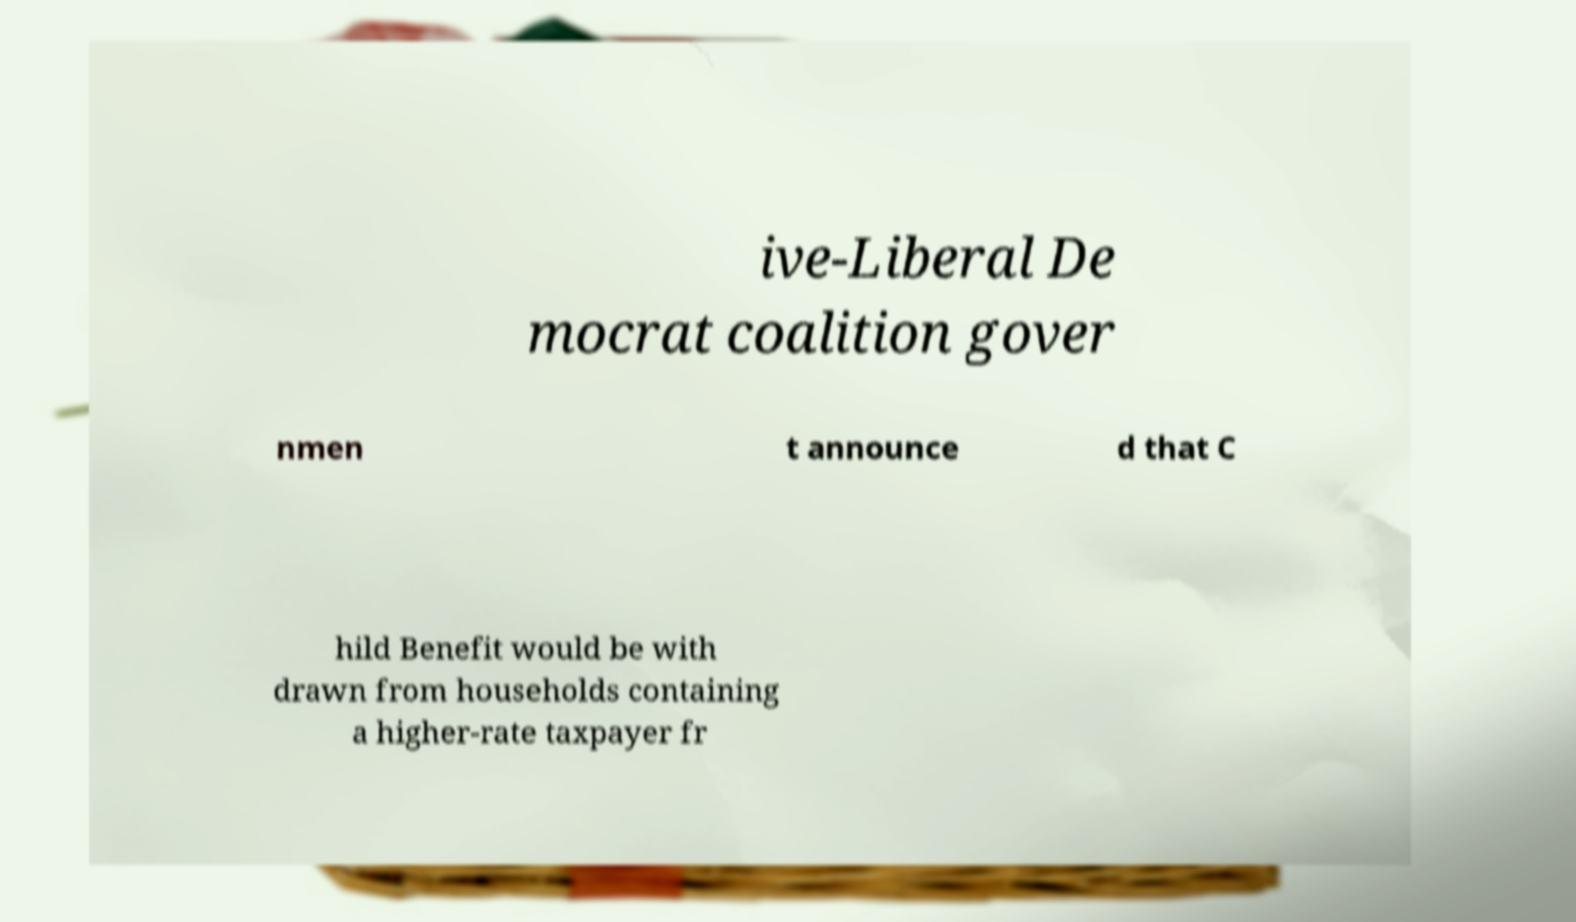Can you accurately transcribe the text from the provided image for me? ive-Liberal De mocrat coalition gover nmen t announce d that C hild Benefit would be with drawn from households containing a higher-rate taxpayer fr 